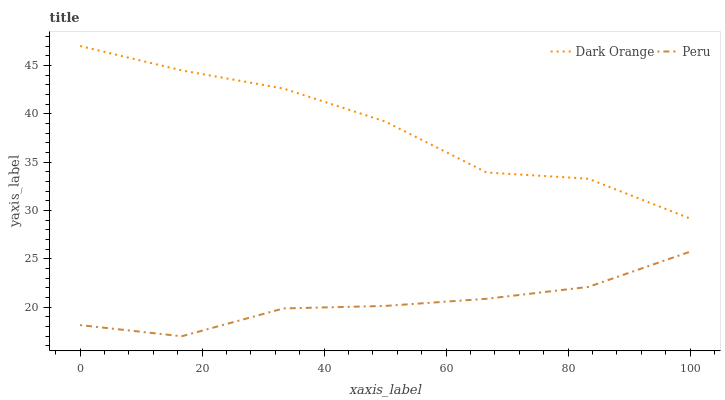Does Peru have the minimum area under the curve?
Answer yes or no. Yes. Does Dark Orange have the maximum area under the curve?
Answer yes or no. Yes. Does Peru have the maximum area under the curve?
Answer yes or no. No. Is Peru the smoothest?
Answer yes or no. Yes. Is Dark Orange the roughest?
Answer yes or no. Yes. Is Peru the roughest?
Answer yes or no. No. Does Dark Orange have the highest value?
Answer yes or no. Yes. Does Peru have the highest value?
Answer yes or no. No. Is Peru less than Dark Orange?
Answer yes or no. Yes. Is Dark Orange greater than Peru?
Answer yes or no. Yes. Does Peru intersect Dark Orange?
Answer yes or no. No. 